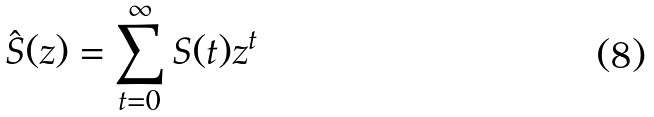<formula> <loc_0><loc_0><loc_500><loc_500>\hat { S } ( z ) = \sum _ { t = 0 } ^ { \infty } S ( t ) z ^ { t }</formula> 